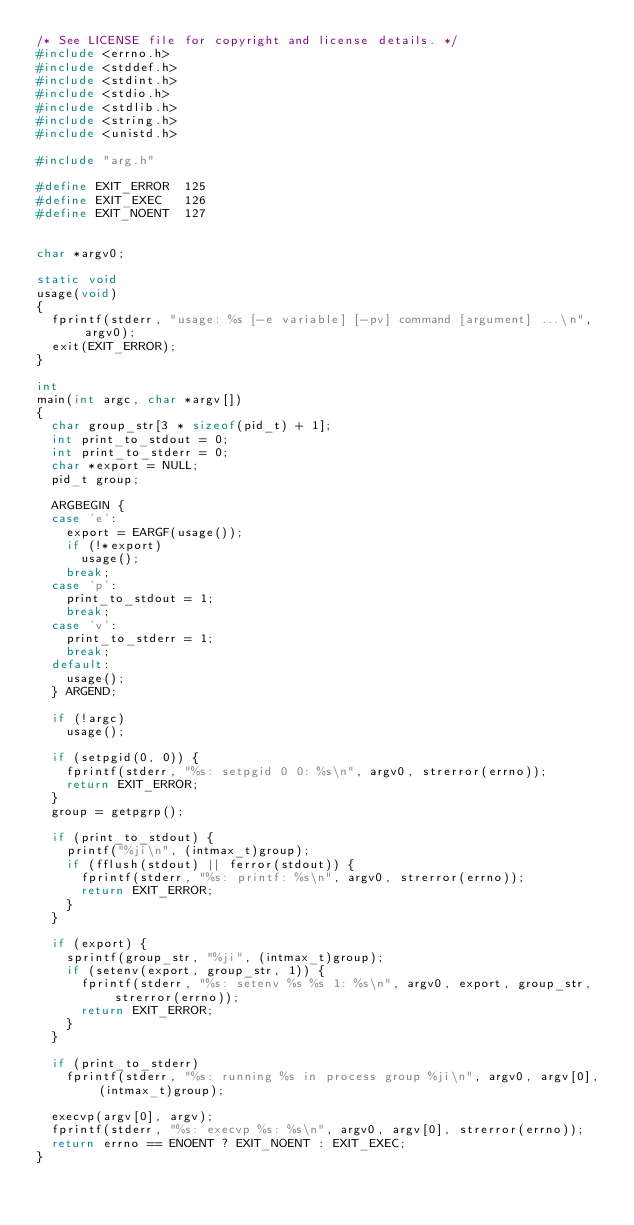<code> <loc_0><loc_0><loc_500><loc_500><_C_>/* See LICENSE file for copyright and license details. */
#include <errno.h>
#include <stddef.h>
#include <stdint.h>
#include <stdio.h>
#include <stdlib.h>
#include <string.h>
#include <unistd.h>

#include "arg.h"

#define EXIT_ERROR  125
#define EXIT_EXEC   126
#define EXIT_NOENT  127


char *argv0;

static void
usage(void)
{
	fprintf(stderr, "usage: %s [-e variable] [-pv] command [argument] ...\n", argv0);
	exit(EXIT_ERROR);
}

int
main(int argc, char *argv[])
{
	char group_str[3 * sizeof(pid_t) + 1];
	int print_to_stdout = 0;
	int print_to_stderr = 0;
	char *export = NULL;
	pid_t group;

	ARGBEGIN {
	case 'e':
		export = EARGF(usage());
		if (!*export)
			usage();
		break;
	case 'p':
		print_to_stdout = 1;
		break;
	case 'v':
		print_to_stderr = 1;
		break;
	default:
		usage();
	} ARGEND;

	if (!argc)
		usage();

	if (setpgid(0, 0)) {
		fprintf(stderr, "%s: setpgid 0 0: %s\n", argv0, strerror(errno));
		return EXIT_ERROR;
	}
	group = getpgrp();

	if (print_to_stdout) {
		printf("%ji\n", (intmax_t)group);
		if (fflush(stdout) || ferror(stdout)) {
			fprintf(stderr, "%s: printf: %s\n", argv0, strerror(errno));
			return EXIT_ERROR;
		}
	}

	if (export) {
		sprintf(group_str, "%ji", (intmax_t)group);
		if (setenv(export, group_str, 1)) {
			fprintf(stderr, "%s: setenv %s %s 1: %s\n", argv0, export, group_str, strerror(errno));
			return EXIT_ERROR;
		}
	}

	if (print_to_stderr)
		fprintf(stderr, "%s: running %s in process group %ji\n", argv0, argv[0], (intmax_t)group);

	execvp(argv[0], argv);
	fprintf(stderr, "%s: execvp %s: %s\n", argv0, argv[0], strerror(errno));
	return errno == ENOENT ? EXIT_NOENT : EXIT_EXEC;
}
</code> 